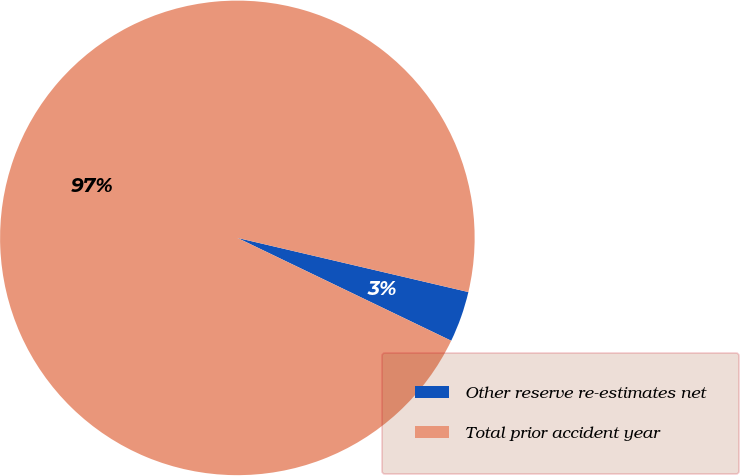Convert chart to OTSL. <chart><loc_0><loc_0><loc_500><loc_500><pie_chart><fcel>Other reserve re-estimates net<fcel>Total prior accident year<nl><fcel>3.47%<fcel>96.53%<nl></chart> 